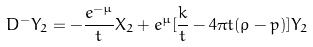Convert formula to latex. <formula><loc_0><loc_0><loc_500><loc_500>D ^ { - } Y _ { 2 } = - \frac { e ^ { - \mu } } { t } X _ { 2 } + e ^ { \mu } [ \frac { k } { t } - 4 \pi t ( \rho - p ) ] Y _ { 2 }</formula> 